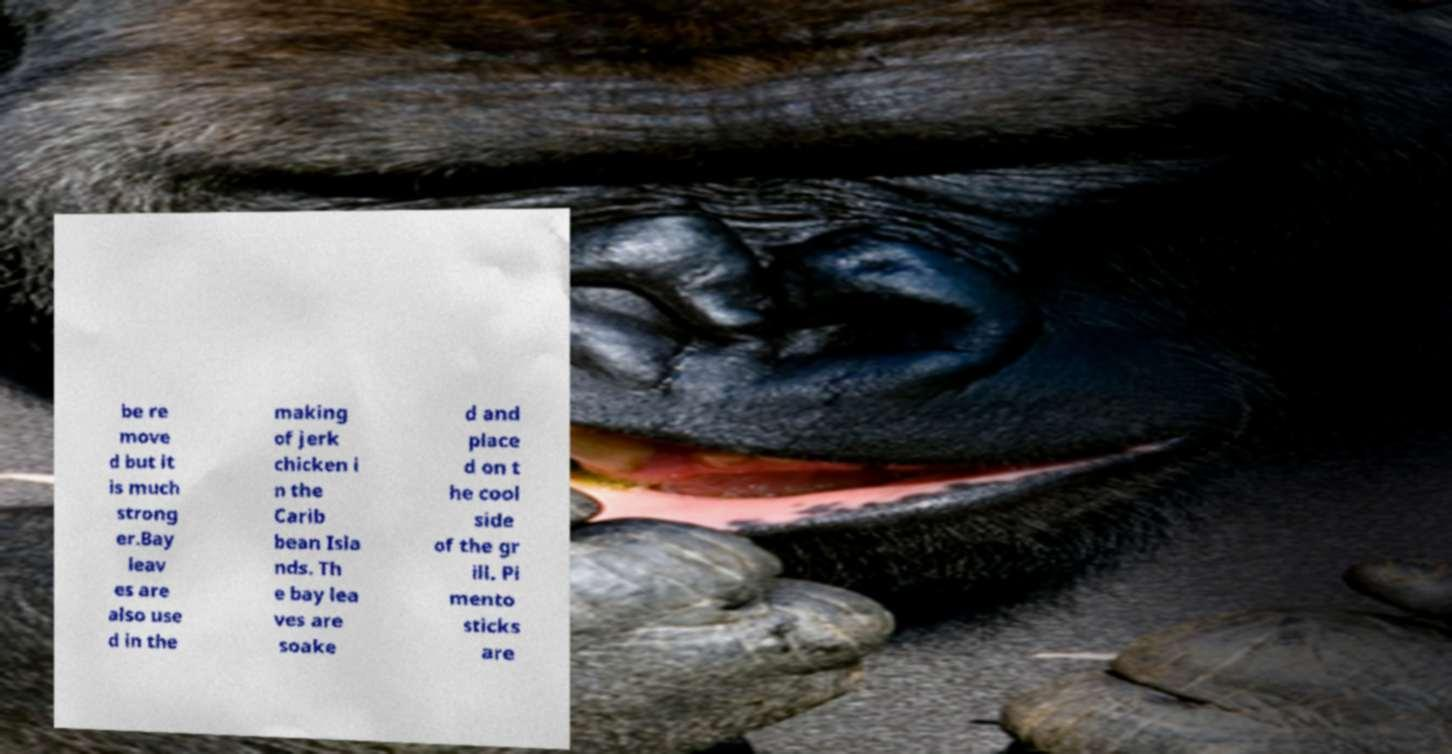I need the written content from this picture converted into text. Can you do that? be re move d but it is much strong er.Bay leav es are also use d in the making of jerk chicken i n the Carib bean Isla nds. Th e bay lea ves are soake d and place d on t he cool side of the gr ill. Pi mento sticks are 